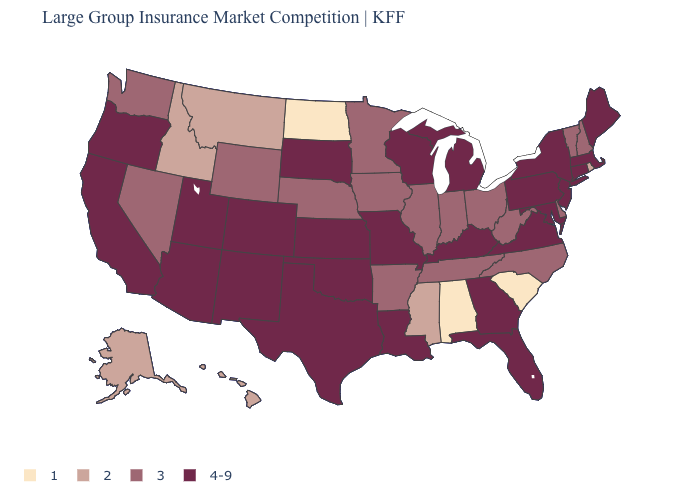Does the map have missing data?
Give a very brief answer. No. Among the states that border Maryland , which have the lowest value?
Answer briefly. Delaware, West Virginia. Name the states that have a value in the range 2?
Keep it brief. Alaska, Hawaii, Idaho, Mississippi, Montana, Rhode Island. What is the value of Virginia?
Answer briefly. 4-9. What is the value of North Carolina?
Be succinct. 3. Is the legend a continuous bar?
Keep it brief. No. What is the value of South Carolina?
Be succinct. 1. What is the lowest value in the West?
Give a very brief answer. 2. Does the map have missing data?
Concise answer only. No. Name the states that have a value in the range 2?
Give a very brief answer. Alaska, Hawaii, Idaho, Mississippi, Montana, Rhode Island. Which states have the lowest value in the USA?
Quick response, please. Alabama, North Dakota, South Carolina. Among the states that border California , does Nevada have the lowest value?
Give a very brief answer. Yes. Name the states that have a value in the range 1?
Concise answer only. Alabama, North Dakota, South Carolina. Does the map have missing data?
Be succinct. No. What is the value of Arkansas?
Concise answer only. 3. 